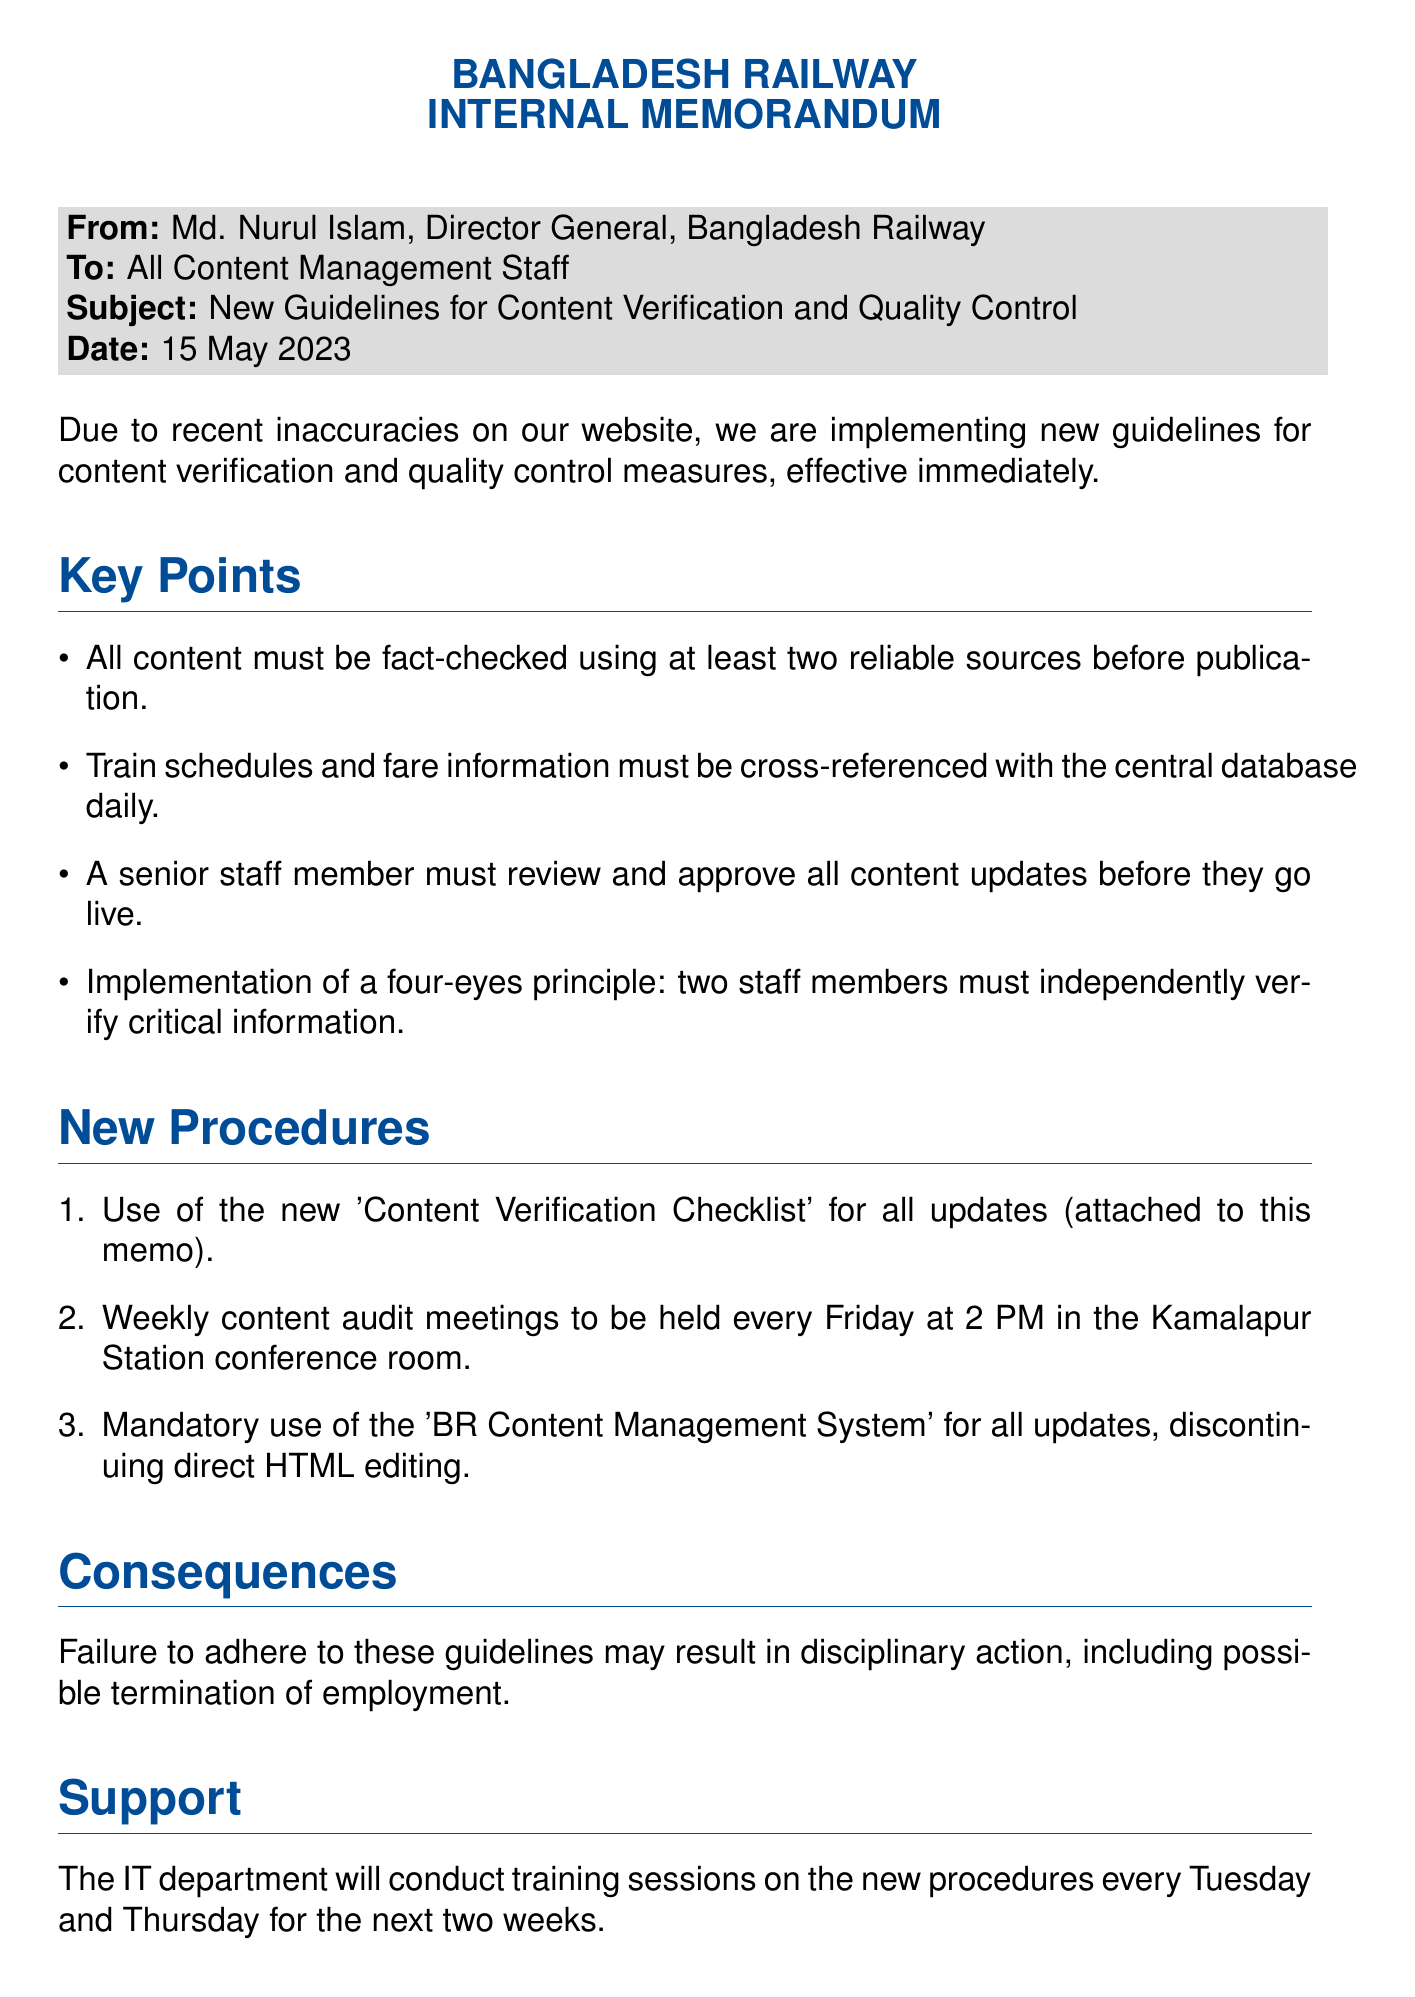what is the name of the Director General? The document specifies that the Director General is Md. Nurul Islam.
Answer: Md. Nurul Islam what is the date of the memo? The memo states the date is 15 May 2023.
Answer: 15 May 2023 how many content audit meetings are scheduled each week? According to the procedures, weekly content audit meetings are to be held every Friday, indicating one meeting per week.
Answer: One what must be used for all updates? The memo mandates the use of the 'BR Content Management System' for all updates.
Answer: 'BR Content Management System' how many reliable sources should be used for fact-checking? The guidelines indicate that all content must be fact-checked using at least two reliable sources.
Answer: Two what are the consequences of not adhering to the guidelines? The memo states that failure to follow these guidelines may lead to disciplinary action, including possible termination.
Answer: Termination when are the training sessions conducted? The IT department will conduct training sessions every Tuesday and Thursday for the next two weeks.
Answer: Tuesday and Thursday what is the "four-eyes principle"? The document describes the "four-eyes principle" as requiring two staff members to independently verify critical information.
Answer: Two staff members who is the intended audience of the memo? The memo is addressed to all content management staff.
Answer: All Content Management Staff 